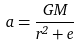<formula> <loc_0><loc_0><loc_500><loc_500>a = \frac { G M } { r ^ { 2 } + e }</formula> 